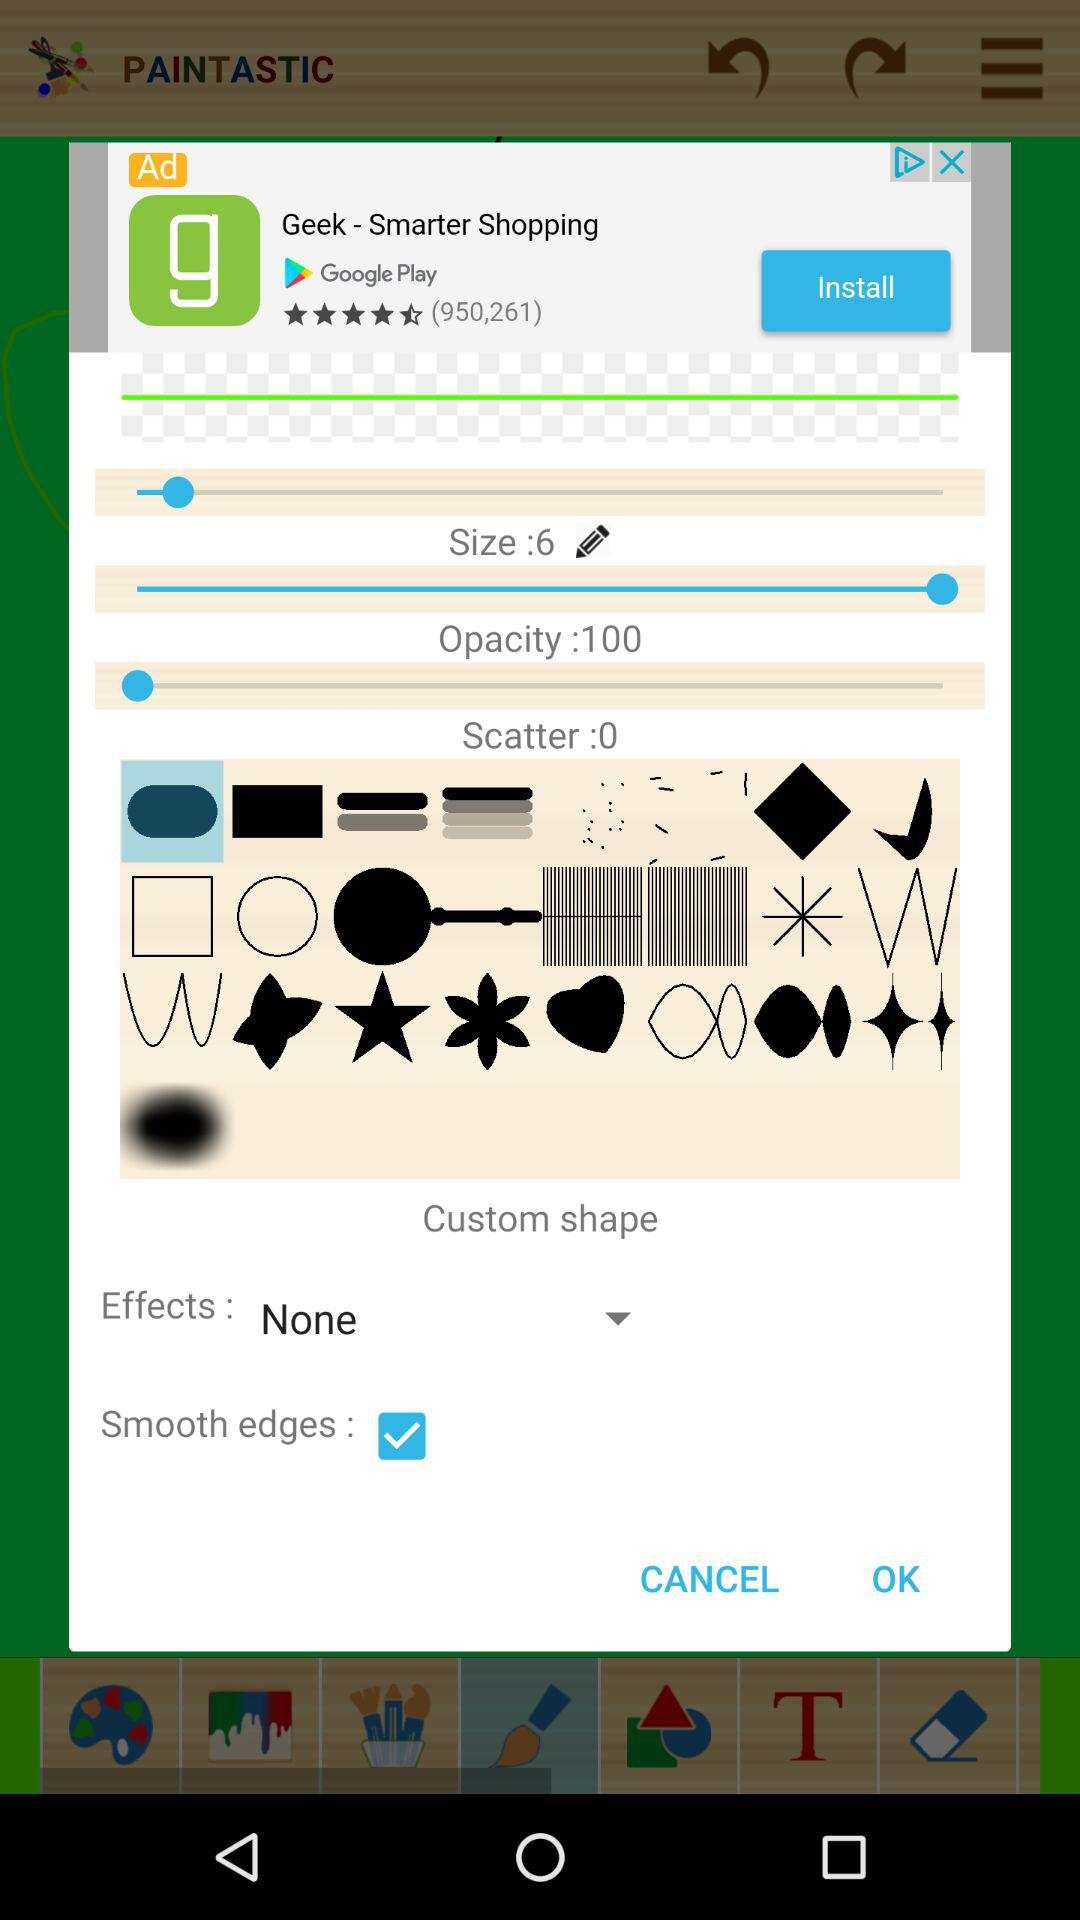What is the status of "Smooth edges"? The status is "on". 